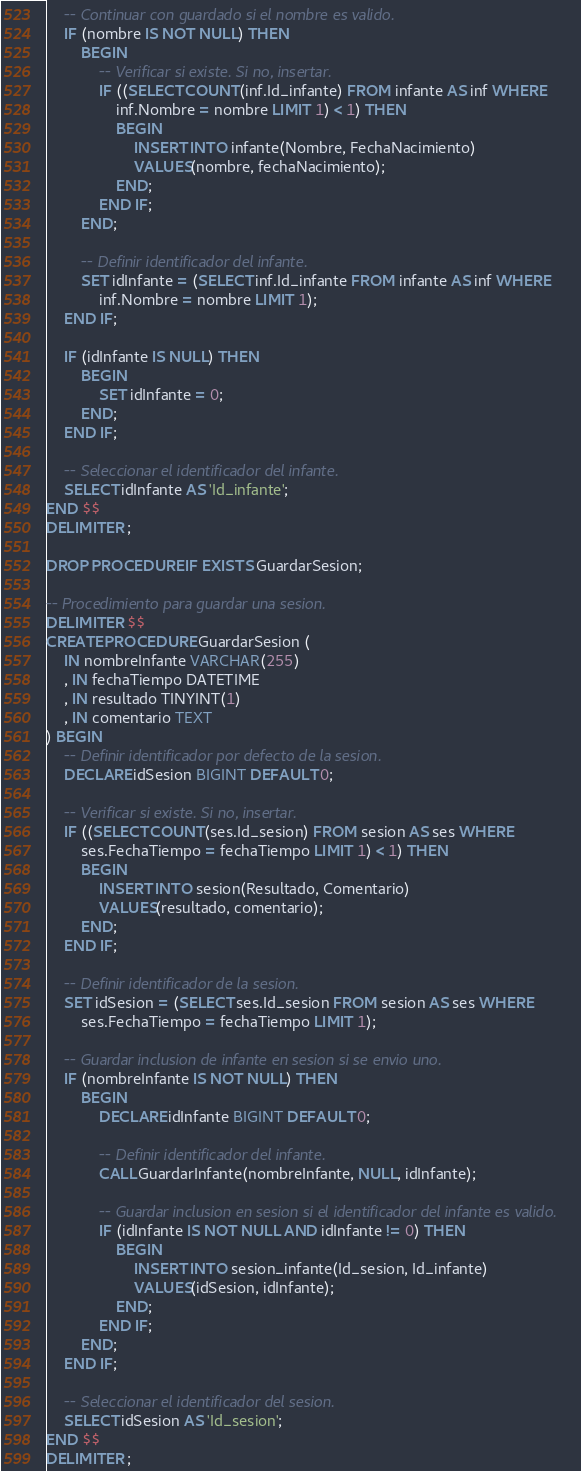Convert code to text. <code><loc_0><loc_0><loc_500><loc_500><_SQL_>    -- Continuar con guardado si el nombre es valido.
    IF (nombre IS NOT NULL) THEN
        BEGIN
            -- Verificar si existe. Si no, insertar.
			IF ((SELECT COUNT(inf.Id_infante) FROM infante AS inf WHERE
				inf.Nombre = nombre LIMIT 1) < 1) THEN
                BEGIN
                    INSERT INTO infante(Nombre, FechaNacimiento)
                    VALUES(nombre, fechaNacimiento);
                END;
            END IF;
        END;

        -- Definir identificador del infante.
        SET idInfante = (SELECT inf.Id_infante FROM infante AS inf WHERE
            inf.Nombre = nombre LIMIT 1);
    END IF;

	IF (idInfante IS NULL) THEN
		BEGIN
			SET idInfante = 0;
		END;
	END IF;

    -- Seleccionar el identificador del infante.
    SELECT idInfante AS 'Id_infante';
END $$
DELIMITER ;

DROP PROCEDURE IF EXISTS GuardarSesion;

-- Procedimiento para guardar una sesion.
DELIMITER $$
CREATE PROCEDURE GuardarSesion (
	IN nombreInfante VARCHAR(255)
	, IN fechaTiempo DATETIME
    , IN resultado TINYINT(1)
    , IN comentario TEXT
) BEGIN
    -- Definir identificador por defecto de la sesion.
    DECLARE idSesion BIGINT DEFAULT 0;

	-- Verificar si existe. Si no, insertar.
	IF ((SELECT COUNT(ses.Id_sesion) FROM sesion AS ses WHERE
		ses.FechaTiempo = fechaTiempo LIMIT 1) < 1) THEN
		BEGIN
			INSERT INTO sesion(Resultado, Comentario)
			VALUES(resultado, comentario);
		END;
	END IF;

	-- Definir identificador de la sesion.
	SET idSesion = (SELECT ses.Id_sesion FROM sesion AS ses WHERE
		ses.FechaTiempo = fechaTiempo LIMIT 1);

	-- Guardar inclusion de infante en sesion si se envio uno.
	IF (nombreInfante IS NOT NULL) THEN
		BEGIN
			DECLARE idInfante BIGINT DEFAULT 0;

			-- Definir identificador del infante.
			CALL GuardarInfante(nombreInfante, NULL, idInfante);

			-- Guardar inclusion en sesion si el identificador del infante es valido.
			IF (idInfante IS NOT NULL AND idInfante != 0) THEN
				BEGIN
					INSERT INTO sesion_infante(Id_sesion, Id_infante)
					VALUES(idSesion, idInfante);
				END;
			END IF;
		END;
	END IF;

    -- Seleccionar el identificador del sesion.
    SELECT idSesion AS 'Id_sesion';
END $$
DELIMITER ;
</code> 